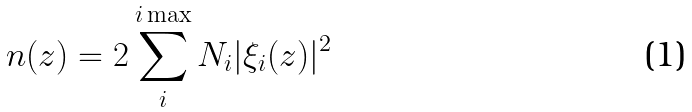Convert formula to latex. <formula><loc_0><loc_0><loc_500><loc_500>n ( z ) = 2 \sum _ { i } ^ { i \max } N _ { i } | \xi _ { i } ( z ) | ^ { 2 }</formula> 